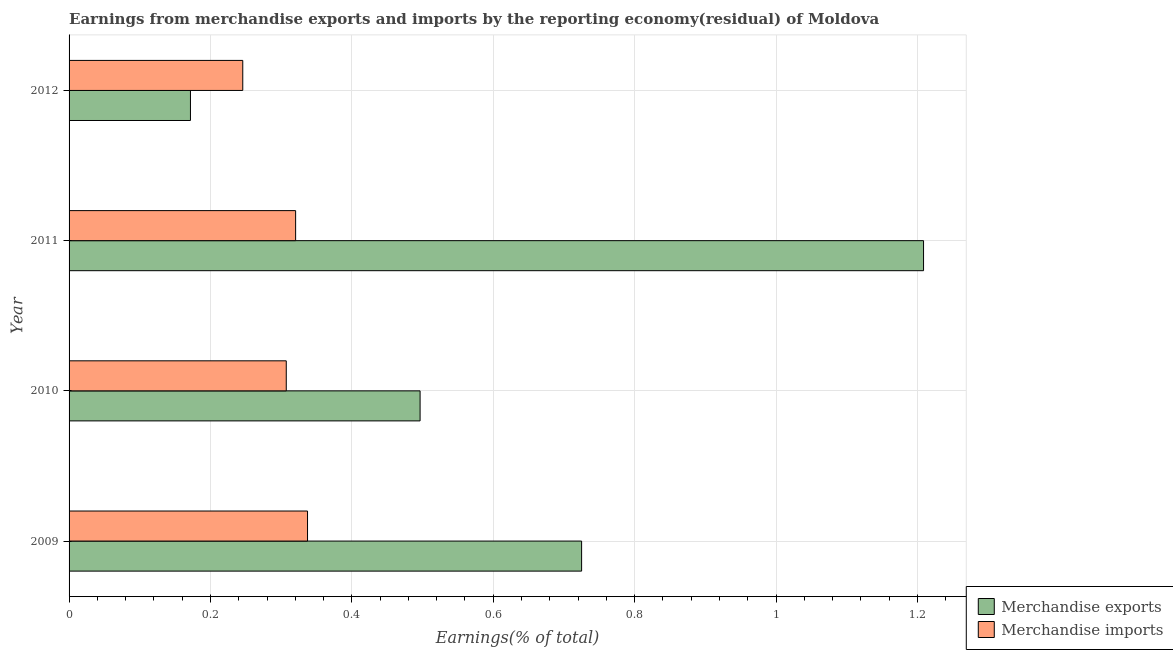How many groups of bars are there?
Your answer should be very brief. 4. Are the number of bars per tick equal to the number of legend labels?
Make the answer very short. Yes. Are the number of bars on each tick of the Y-axis equal?
Provide a succinct answer. Yes. How many bars are there on the 1st tick from the bottom?
Keep it short and to the point. 2. What is the label of the 3rd group of bars from the top?
Your answer should be compact. 2010. In how many cases, is the number of bars for a given year not equal to the number of legend labels?
Keep it short and to the point. 0. What is the earnings from merchandise imports in 2010?
Keep it short and to the point. 0.31. Across all years, what is the maximum earnings from merchandise imports?
Offer a terse response. 0.34. Across all years, what is the minimum earnings from merchandise exports?
Your answer should be compact. 0.17. What is the total earnings from merchandise imports in the graph?
Ensure brevity in your answer.  1.21. What is the difference between the earnings from merchandise imports in 2009 and that in 2011?
Your response must be concise. 0.02. What is the difference between the earnings from merchandise imports in 2010 and the earnings from merchandise exports in 2011?
Offer a terse response. -0.9. What is the average earnings from merchandise exports per year?
Provide a succinct answer. 0.65. In the year 2009, what is the difference between the earnings from merchandise exports and earnings from merchandise imports?
Your answer should be compact. 0.39. In how many years, is the earnings from merchandise imports greater than 0.9600000000000001 %?
Make the answer very short. 0. What is the ratio of the earnings from merchandise exports in 2010 to that in 2012?
Provide a succinct answer. 2.89. Is the earnings from merchandise imports in 2009 less than that in 2012?
Give a very brief answer. No. What is the difference between the highest and the second highest earnings from merchandise imports?
Give a very brief answer. 0.02. What does the 2nd bar from the top in 2011 represents?
Provide a succinct answer. Merchandise exports. What does the 1st bar from the bottom in 2010 represents?
Offer a very short reply. Merchandise exports. How many bars are there?
Offer a very short reply. 8. How many years are there in the graph?
Make the answer very short. 4. Are the values on the major ticks of X-axis written in scientific E-notation?
Ensure brevity in your answer.  No. Does the graph contain grids?
Ensure brevity in your answer.  Yes. How many legend labels are there?
Your answer should be compact. 2. What is the title of the graph?
Offer a very short reply. Earnings from merchandise exports and imports by the reporting economy(residual) of Moldova. Does "Borrowers" appear as one of the legend labels in the graph?
Your response must be concise. No. What is the label or title of the X-axis?
Ensure brevity in your answer.  Earnings(% of total). What is the label or title of the Y-axis?
Make the answer very short. Year. What is the Earnings(% of total) of Merchandise exports in 2009?
Your response must be concise. 0.73. What is the Earnings(% of total) of Merchandise imports in 2009?
Give a very brief answer. 0.34. What is the Earnings(% of total) of Merchandise exports in 2010?
Give a very brief answer. 0.5. What is the Earnings(% of total) of Merchandise imports in 2010?
Offer a very short reply. 0.31. What is the Earnings(% of total) of Merchandise exports in 2011?
Provide a succinct answer. 1.21. What is the Earnings(% of total) of Merchandise imports in 2011?
Ensure brevity in your answer.  0.32. What is the Earnings(% of total) in Merchandise exports in 2012?
Make the answer very short. 0.17. What is the Earnings(% of total) of Merchandise imports in 2012?
Provide a short and direct response. 0.25. Across all years, what is the maximum Earnings(% of total) in Merchandise exports?
Ensure brevity in your answer.  1.21. Across all years, what is the maximum Earnings(% of total) in Merchandise imports?
Ensure brevity in your answer.  0.34. Across all years, what is the minimum Earnings(% of total) in Merchandise exports?
Keep it short and to the point. 0.17. Across all years, what is the minimum Earnings(% of total) in Merchandise imports?
Give a very brief answer. 0.25. What is the total Earnings(% of total) in Merchandise exports in the graph?
Provide a succinct answer. 2.6. What is the total Earnings(% of total) of Merchandise imports in the graph?
Your response must be concise. 1.21. What is the difference between the Earnings(% of total) in Merchandise exports in 2009 and that in 2010?
Your answer should be very brief. 0.23. What is the difference between the Earnings(% of total) of Merchandise imports in 2009 and that in 2010?
Your answer should be very brief. 0.03. What is the difference between the Earnings(% of total) of Merchandise exports in 2009 and that in 2011?
Offer a very short reply. -0.48. What is the difference between the Earnings(% of total) in Merchandise imports in 2009 and that in 2011?
Your answer should be compact. 0.02. What is the difference between the Earnings(% of total) of Merchandise exports in 2009 and that in 2012?
Offer a very short reply. 0.55. What is the difference between the Earnings(% of total) of Merchandise imports in 2009 and that in 2012?
Keep it short and to the point. 0.09. What is the difference between the Earnings(% of total) in Merchandise exports in 2010 and that in 2011?
Offer a very short reply. -0.71. What is the difference between the Earnings(% of total) of Merchandise imports in 2010 and that in 2011?
Ensure brevity in your answer.  -0.01. What is the difference between the Earnings(% of total) of Merchandise exports in 2010 and that in 2012?
Ensure brevity in your answer.  0.32. What is the difference between the Earnings(% of total) of Merchandise imports in 2010 and that in 2012?
Provide a succinct answer. 0.06. What is the difference between the Earnings(% of total) of Merchandise imports in 2011 and that in 2012?
Your answer should be very brief. 0.07. What is the difference between the Earnings(% of total) of Merchandise exports in 2009 and the Earnings(% of total) of Merchandise imports in 2010?
Give a very brief answer. 0.42. What is the difference between the Earnings(% of total) in Merchandise exports in 2009 and the Earnings(% of total) in Merchandise imports in 2011?
Your answer should be compact. 0.4. What is the difference between the Earnings(% of total) of Merchandise exports in 2009 and the Earnings(% of total) of Merchandise imports in 2012?
Your answer should be compact. 0.48. What is the difference between the Earnings(% of total) in Merchandise exports in 2010 and the Earnings(% of total) in Merchandise imports in 2011?
Provide a short and direct response. 0.18. What is the difference between the Earnings(% of total) of Merchandise exports in 2010 and the Earnings(% of total) of Merchandise imports in 2012?
Make the answer very short. 0.25. What is the average Earnings(% of total) in Merchandise exports per year?
Your response must be concise. 0.65. What is the average Earnings(% of total) of Merchandise imports per year?
Provide a succinct answer. 0.3. In the year 2009, what is the difference between the Earnings(% of total) of Merchandise exports and Earnings(% of total) of Merchandise imports?
Offer a terse response. 0.39. In the year 2010, what is the difference between the Earnings(% of total) in Merchandise exports and Earnings(% of total) in Merchandise imports?
Ensure brevity in your answer.  0.19. In the year 2011, what is the difference between the Earnings(% of total) in Merchandise exports and Earnings(% of total) in Merchandise imports?
Your answer should be compact. 0.89. In the year 2012, what is the difference between the Earnings(% of total) in Merchandise exports and Earnings(% of total) in Merchandise imports?
Your answer should be compact. -0.07. What is the ratio of the Earnings(% of total) in Merchandise exports in 2009 to that in 2010?
Offer a very short reply. 1.46. What is the ratio of the Earnings(% of total) in Merchandise imports in 2009 to that in 2010?
Your response must be concise. 1.1. What is the ratio of the Earnings(% of total) in Merchandise exports in 2009 to that in 2011?
Provide a short and direct response. 0.6. What is the ratio of the Earnings(% of total) of Merchandise imports in 2009 to that in 2011?
Give a very brief answer. 1.05. What is the ratio of the Earnings(% of total) in Merchandise exports in 2009 to that in 2012?
Provide a short and direct response. 4.22. What is the ratio of the Earnings(% of total) of Merchandise imports in 2009 to that in 2012?
Offer a very short reply. 1.37. What is the ratio of the Earnings(% of total) of Merchandise exports in 2010 to that in 2011?
Give a very brief answer. 0.41. What is the ratio of the Earnings(% of total) in Merchandise imports in 2010 to that in 2011?
Your answer should be compact. 0.96. What is the ratio of the Earnings(% of total) in Merchandise exports in 2010 to that in 2012?
Provide a succinct answer. 2.89. What is the ratio of the Earnings(% of total) of Merchandise imports in 2010 to that in 2012?
Provide a succinct answer. 1.25. What is the ratio of the Earnings(% of total) in Merchandise exports in 2011 to that in 2012?
Ensure brevity in your answer.  7.04. What is the ratio of the Earnings(% of total) of Merchandise imports in 2011 to that in 2012?
Offer a very short reply. 1.3. What is the difference between the highest and the second highest Earnings(% of total) in Merchandise exports?
Your response must be concise. 0.48. What is the difference between the highest and the second highest Earnings(% of total) of Merchandise imports?
Your answer should be very brief. 0.02. What is the difference between the highest and the lowest Earnings(% of total) in Merchandise exports?
Give a very brief answer. 1.04. What is the difference between the highest and the lowest Earnings(% of total) of Merchandise imports?
Provide a succinct answer. 0.09. 